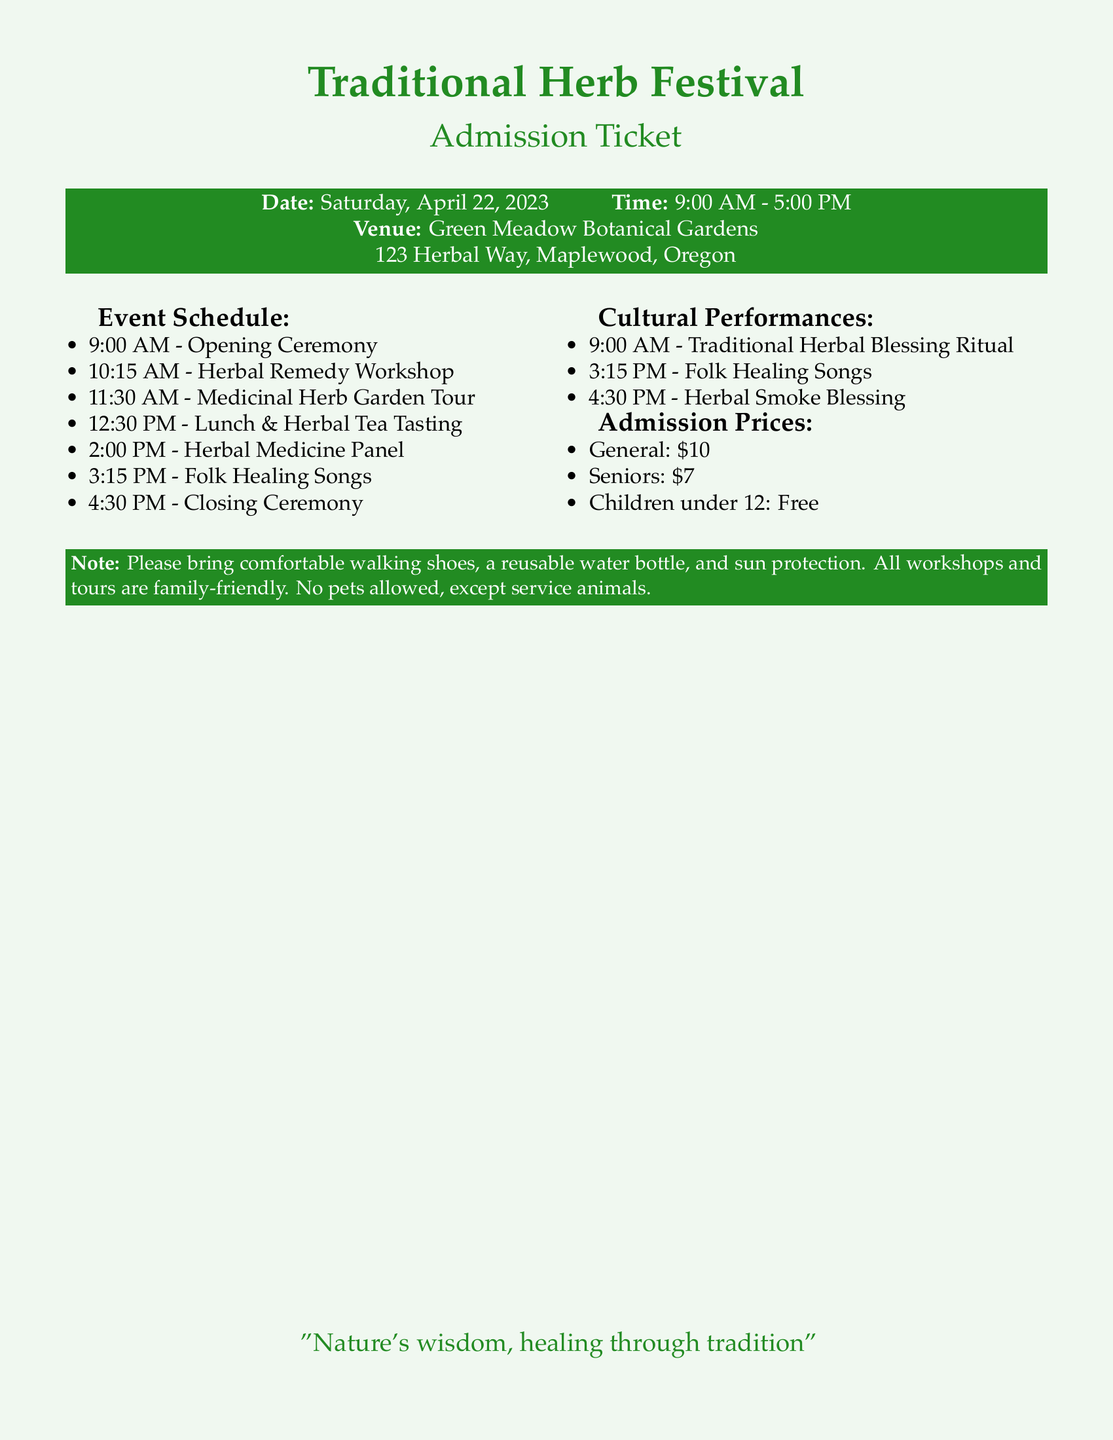what is the date of the festival? The date of the festival is explicitly mentioned in the document as Saturday, April 22, 2023.
Answer: Saturday, April 22, 2023 what time does the festival start? The start time of the festival is indicated in the document as 9:00 AM.
Answer: 9:00 AM where is the festival taking place? The location of the festival is provided in the document, which states the venue as Green Meadow Botanical Gardens.
Answer: Green Meadow Botanical Gardens how much does a general admission ticket cost? The cost of a general admission ticket is noted in the document under Admission Prices as $10.
Answer: $10 what is one of the cultural performances listed in the document? The document lists several cultural performances, including the traditional herbal blessing ritual.
Answer: Traditional Herbal Blessing Ritual how long is the Herbal Remedy Workshop? The Herbal Remedy Workshop starts at 10:15 AM and there is no specific end time mentioned, but it can be inferred to last until the next scheduled event, which is at 11:30 AM, making it approximately 1 hour and 15 minutes.
Answer: 1 hour and 15 minutes which performance occurs after lunch? The document lists the event schedule, showing that the first item after lunch is the Herbal Medicine Panel at 2:00 PM.
Answer: Herbal Medicine Panel how many admission prices are listed? The document outlines three distinct admission prices for different categories: General, Seniors, and Children under 12.
Answer: Three what should attendees bring to the festival? A note in the document suggests attendees bring comfortable walking shoes, a reusable water bottle, and sun protection.
Answer: Comfortable walking shoes, a reusable water bottle, and sun protection 